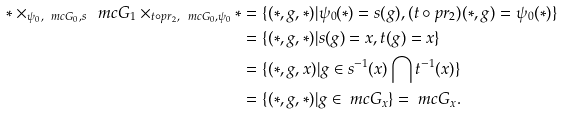<formula> <loc_0><loc_0><loc_500><loc_500>* \times _ { \psi _ { 0 } , \ m c { G } _ { 0 } , s } \ m c { G } _ { 1 } \times _ { t \circ p r _ { 2 } , \ m c { G } _ { 0 } , \psi _ { 0 } } * & = \{ ( * , g , * ) | \psi _ { 0 } ( * ) = s ( g ) , ( t \circ p r _ { 2 } ) ( * , g ) = \psi _ { 0 } ( * ) \} \\ & = \{ ( * , g , * ) | s ( g ) = x , t ( g ) = x \} \\ & = \{ ( * , g , x ) | g \in s ^ { - 1 } ( x ) \bigcap t ^ { - 1 } ( x ) \} \\ & = \{ ( * , g , * ) | g \in \ m c { G } _ { x } \} = \ m c { G } _ { x } .</formula> 